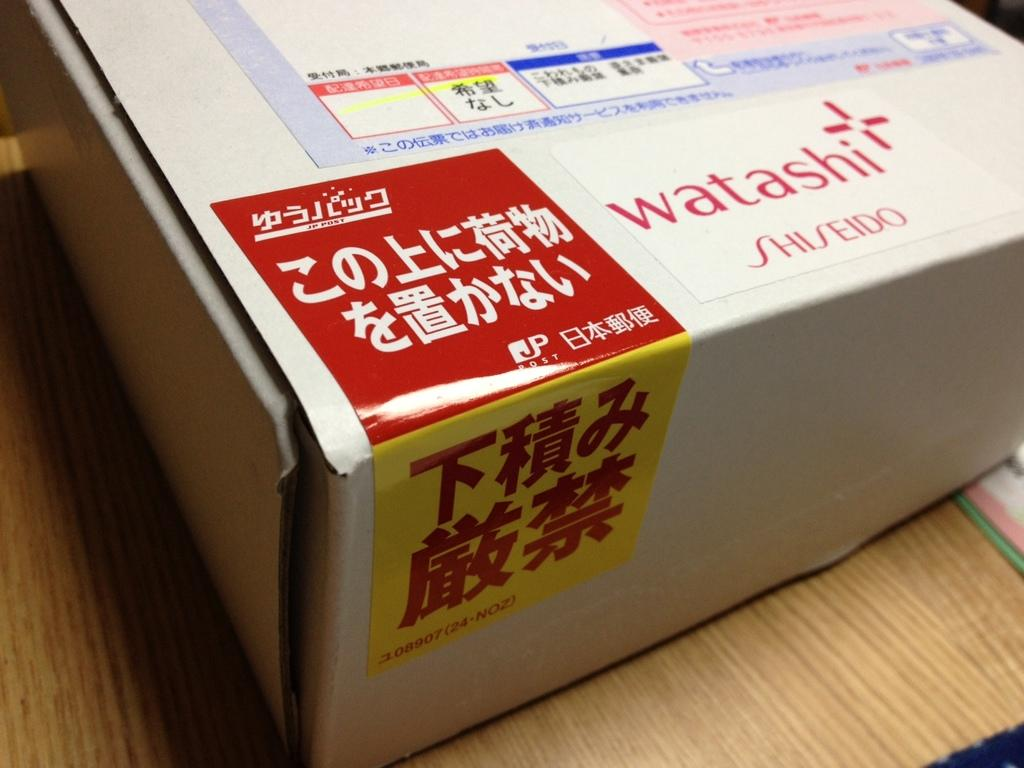<image>
Write a terse but informative summary of the picture. A box has the watashi logo on it in red lettering. 